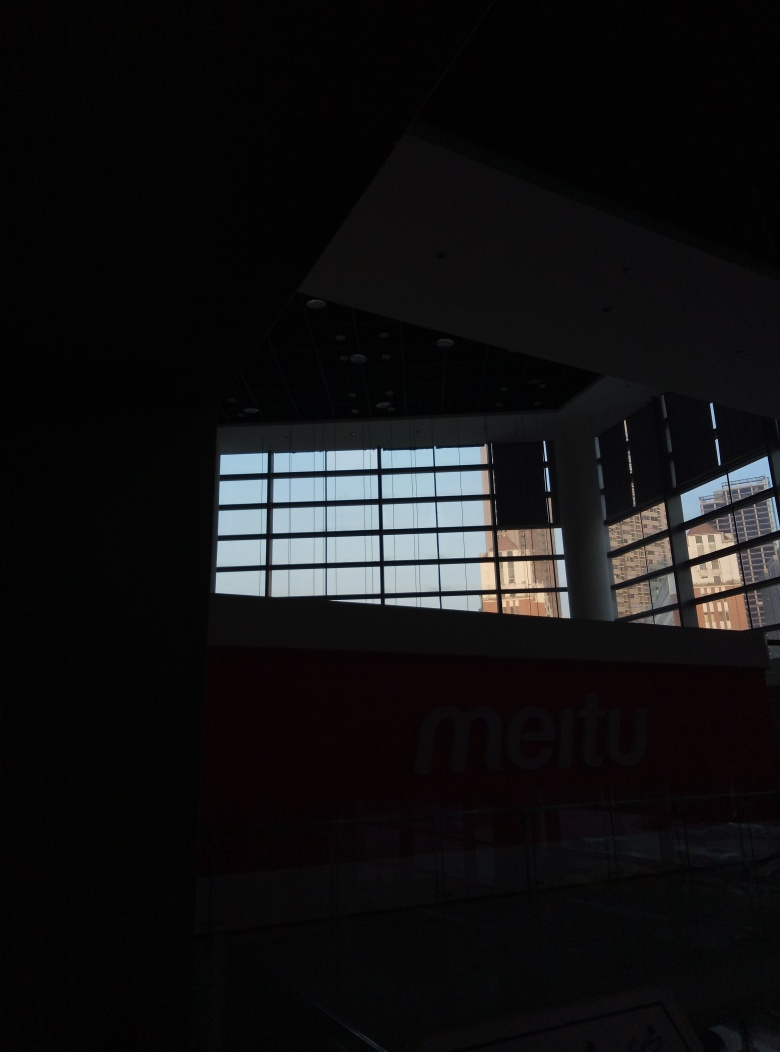What time of day does this photo appear to be taken? The photo appears to be taken around dusk or dawn, given the lit condition outside the window and the darkness within the indoor area. The exact time cannot be precisely determined without more context. 